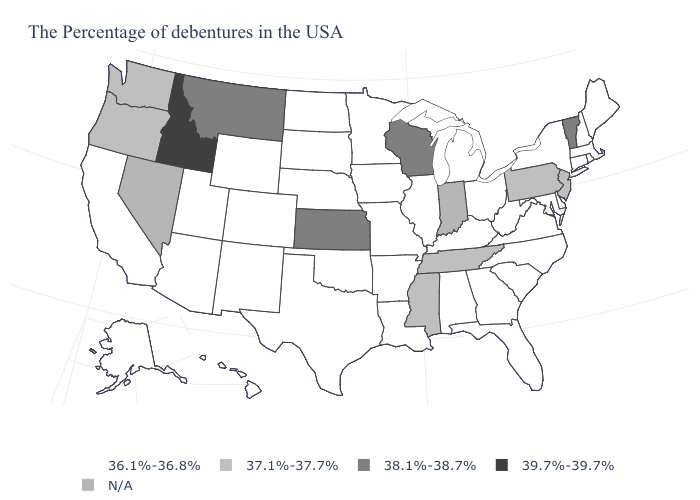What is the value of Maine?
Quick response, please. 36.1%-36.8%. Name the states that have a value in the range 37.1%-37.7%?
Be succinct. New Jersey, Pennsylvania, Tennessee, Mississippi, Washington, Oregon. Among the states that border Mississippi , which have the lowest value?
Write a very short answer. Alabama, Louisiana, Arkansas. Among the states that border Connecticut , which have the highest value?
Short answer required. Massachusetts, Rhode Island, New York. What is the lowest value in states that border Connecticut?
Keep it brief. 36.1%-36.8%. Name the states that have a value in the range N/A?
Be succinct. Indiana, Nevada. Name the states that have a value in the range N/A?
Give a very brief answer. Indiana, Nevada. Name the states that have a value in the range 37.1%-37.7%?
Short answer required. New Jersey, Pennsylvania, Tennessee, Mississippi, Washington, Oregon. How many symbols are there in the legend?
Write a very short answer. 5. What is the value of Michigan?
Concise answer only. 36.1%-36.8%. Among the states that border Missouri , does Kansas have the highest value?
Keep it brief. Yes. Does Tennessee have the lowest value in the USA?
Concise answer only. No. Does Idaho have the highest value in the USA?
Keep it brief. Yes. What is the value of California?
Be succinct. 36.1%-36.8%. 